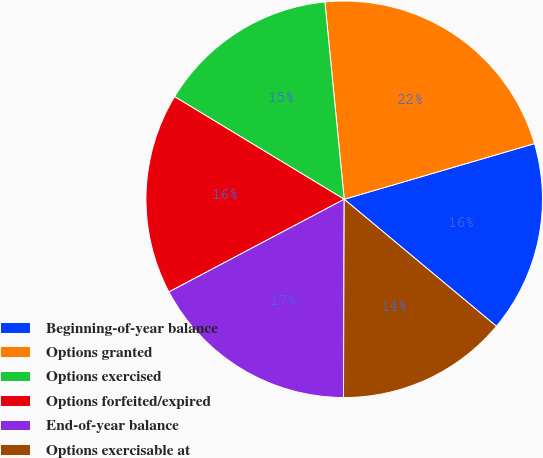Convert chart to OTSL. <chart><loc_0><loc_0><loc_500><loc_500><pie_chart><fcel>Beginning-of-year balance<fcel>Options granted<fcel>Options exercised<fcel>Options forfeited/expired<fcel>End-of-year balance<fcel>Options exercisable at<nl><fcel>15.6%<fcel>22.02%<fcel>14.79%<fcel>16.4%<fcel>17.2%<fcel>13.99%<nl></chart> 